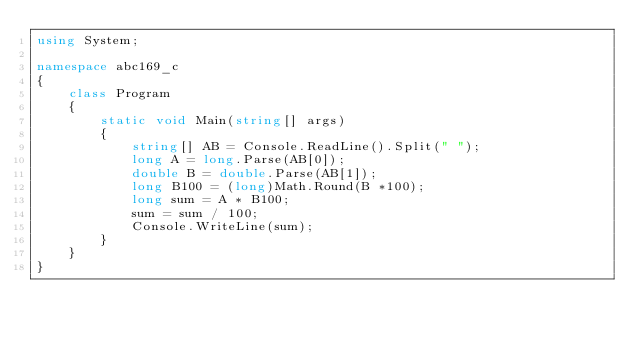Convert code to text. <code><loc_0><loc_0><loc_500><loc_500><_C#_>using System;

namespace abc169_c
{
    class Program
    {
        static void Main(string[] args)
        {
            string[] AB = Console.ReadLine().Split(" ");
            long A = long.Parse(AB[0]);
            double B = double.Parse(AB[1]);
            long B100 = (long)Math.Round(B *100);
            long sum = A * B100;
            sum = sum / 100;
            Console.WriteLine(sum);
        }
    }
}
</code> 